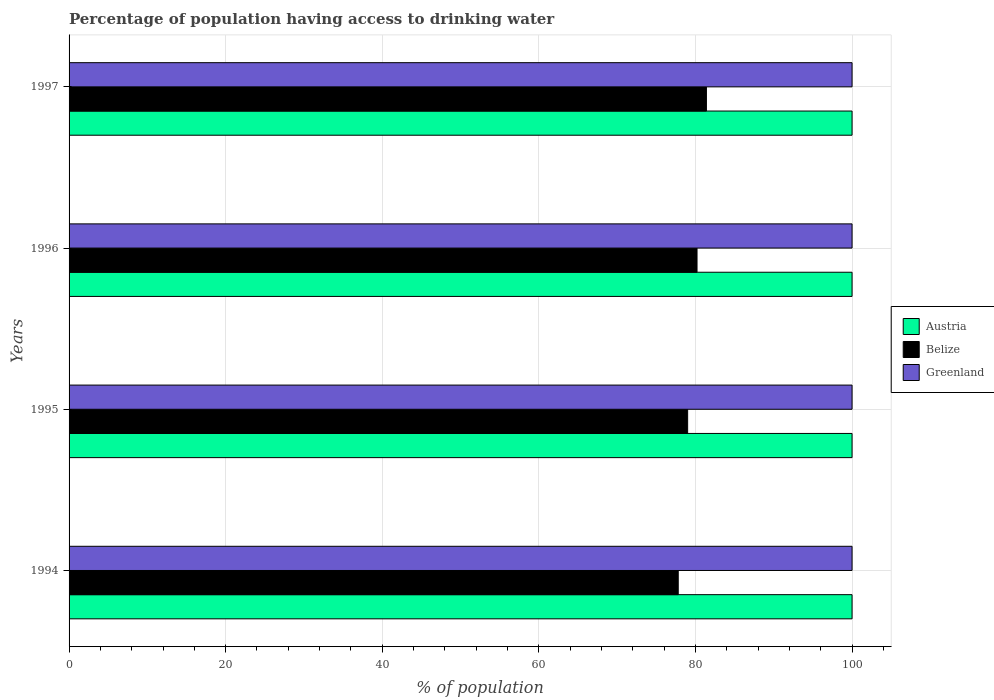How many different coloured bars are there?
Provide a short and direct response. 3. Are the number of bars per tick equal to the number of legend labels?
Your answer should be compact. Yes. Are the number of bars on each tick of the Y-axis equal?
Give a very brief answer. Yes. How many bars are there on the 4th tick from the bottom?
Provide a short and direct response. 3. In how many cases, is the number of bars for a given year not equal to the number of legend labels?
Your answer should be compact. 0. What is the percentage of population having access to drinking water in Belize in 1997?
Provide a succinct answer. 81.4. Across all years, what is the maximum percentage of population having access to drinking water in Austria?
Provide a succinct answer. 100. Across all years, what is the minimum percentage of population having access to drinking water in Belize?
Your answer should be very brief. 77.8. In which year was the percentage of population having access to drinking water in Belize maximum?
Provide a short and direct response. 1997. What is the total percentage of population having access to drinking water in Belize in the graph?
Ensure brevity in your answer.  318.4. What is the difference between the percentage of population having access to drinking water in Belize in 1995 and that in 1997?
Provide a short and direct response. -2.4. What is the difference between the percentage of population having access to drinking water in Greenland in 1996 and the percentage of population having access to drinking water in Austria in 1995?
Your answer should be compact. 0. What is the average percentage of population having access to drinking water in Austria per year?
Keep it short and to the point. 100. In the year 1994, what is the difference between the percentage of population having access to drinking water in Belize and percentage of population having access to drinking water in Greenland?
Your answer should be very brief. -22.2. What is the ratio of the percentage of population having access to drinking water in Austria in 1996 to that in 1997?
Keep it short and to the point. 1. Is the percentage of population having access to drinking water in Greenland in 1995 less than that in 1997?
Your answer should be very brief. No. Is the difference between the percentage of population having access to drinking water in Belize in 1994 and 1995 greater than the difference between the percentage of population having access to drinking water in Greenland in 1994 and 1995?
Your answer should be compact. No. What is the difference between the highest and the second highest percentage of population having access to drinking water in Belize?
Make the answer very short. 1.2. What is the difference between the highest and the lowest percentage of population having access to drinking water in Greenland?
Provide a succinct answer. 0. Is the sum of the percentage of population having access to drinking water in Greenland in 1994 and 1996 greater than the maximum percentage of population having access to drinking water in Austria across all years?
Offer a terse response. Yes. What does the 3rd bar from the bottom in 1995 represents?
Your answer should be compact. Greenland. Is it the case that in every year, the sum of the percentage of population having access to drinking water in Belize and percentage of population having access to drinking water in Austria is greater than the percentage of population having access to drinking water in Greenland?
Your answer should be compact. Yes. How many bars are there?
Provide a short and direct response. 12. What is the difference between two consecutive major ticks on the X-axis?
Your answer should be very brief. 20. Does the graph contain any zero values?
Ensure brevity in your answer.  No. How many legend labels are there?
Keep it short and to the point. 3. What is the title of the graph?
Keep it short and to the point. Percentage of population having access to drinking water. What is the label or title of the X-axis?
Your response must be concise. % of population. What is the % of population of Austria in 1994?
Offer a terse response. 100. What is the % of population of Belize in 1994?
Ensure brevity in your answer.  77.8. What is the % of population of Greenland in 1994?
Offer a terse response. 100. What is the % of population in Austria in 1995?
Make the answer very short. 100. What is the % of population in Belize in 1995?
Provide a short and direct response. 79. What is the % of population of Greenland in 1995?
Make the answer very short. 100. What is the % of population of Austria in 1996?
Offer a very short reply. 100. What is the % of population of Belize in 1996?
Give a very brief answer. 80.2. What is the % of population in Austria in 1997?
Offer a terse response. 100. What is the % of population of Belize in 1997?
Make the answer very short. 81.4. Across all years, what is the maximum % of population of Belize?
Your answer should be compact. 81.4. Across all years, what is the maximum % of population in Greenland?
Offer a very short reply. 100. Across all years, what is the minimum % of population in Austria?
Give a very brief answer. 100. Across all years, what is the minimum % of population in Belize?
Your answer should be compact. 77.8. What is the total % of population in Austria in the graph?
Give a very brief answer. 400. What is the total % of population in Belize in the graph?
Provide a succinct answer. 318.4. What is the difference between the % of population of Austria in 1994 and that in 1995?
Offer a terse response. 0. What is the difference between the % of population of Greenland in 1994 and that in 1995?
Ensure brevity in your answer.  0. What is the difference between the % of population in Belize in 1994 and that in 1996?
Provide a short and direct response. -2.4. What is the difference between the % of population in Greenland in 1994 and that in 1996?
Offer a terse response. 0. What is the difference between the % of population in Austria in 1994 and that in 1997?
Your response must be concise. 0. What is the difference between the % of population in Greenland in 1994 and that in 1997?
Give a very brief answer. 0. What is the difference between the % of population in Belize in 1995 and that in 1997?
Keep it short and to the point. -2.4. What is the difference between the % of population in Greenland in 1995 and that in 1997?
Offer a terse response. 0. What is the difference between the % of population of Austria in 1996 and that in 1997?
Offer a very short reply. 0. What is the difference between the % of population in Belize in 1996 and that in 1997?
Provide a succinct answer. -1.2. What is the difference between the % of population in Greenland in 1996 and that in 1997?
Make the answer very short. 0. What is the difference between the % of population in Austria in 1994 and the % of population in Greenland in 1995?
Offer a very short reply. 0. What is the difference between the % of population of Belize in 1994 and the % of population of Greenland in 1995?
Keep it short and to the point. -22.2. What is the difference between the % of population in Austria in 1994 and the % of population in Belize in 1996?
Provide a succinct answer. 19.8. What is the difference between the % of population of Austria in 1994 and the % of population of Greenland in 1996?
Your answer should be compact. 0. What is the difference between the % of population of Belize in 1994 and the % of population of Greenland in 1996?
Give a very brief answer. -22.2. What is the difference between the % of population in Austria in 1994 and the % of population in Greenland in 1997?
Provide a short and direct response. 0. What is the difference between the % of population of Belize in 1994 and the % of population of Greenland in 1997?
Your answer should be compact. -22.2. What is the difference between the % of population of Austria in 1995 and the % of population of Belize in 1996?
Offer a terse response. 19.8. What is the difference between the % of population of Austria in 1995 and the % of population of Greenland in 1996?
Make the answer very short. 0. What is the difference between the % of population in Austria in 1995 and the % of population in Belize in 1997?
Provide a short and direct response. 18.6. What is the difference between the % of population of Austria in 1995 and the % of population of Greenland in 1997?
Your answer should be very brief. 0. What is the difference between the % of population of Austria in 1996 and the % of population of Greenland in 1997?
Keep it short and to the point. 0. What is the difference between the % of population in Belize in 1996 and the % of population in Greenland in 1997?
Ensure brevity in your answer.  -19.8. What is the average % of population in Austria per year?
Give a very brief answer. 100. What is the average % of population in Belize per year?
Keep it short and to the point. 79.6. What is the average % of population of Greenland per year?
Provide a succinct answer. 100. In the year 1994, what is the difference between the % of population of Austria and % of population of Belize?
Keep it short and to the point. 22.2. In the year 1994, what is the difference between the % of population in Austria and % of population in Greenland?
Make the answer very short. 0. In the year 1994, what is the difference between the % of population in Belize and % of population in Greenland?
Make the answer very short. -22.2. In the year 1995, what is the difference between the % of population of Austria and % of population of Belize?
Provide a short and direct response. 21. In the year 1995, what is the difference between the % of population in Belize and % of population in Greenland?
Keep it short and to the point. -21. In the year 1996, what is the difference between the % of population of Austria and % of population of Belize?
Your answer should be compact. 19.8. In the year 1996, what is the difference between the % of population in Austria and % of population in Greenland?
Give a very brief answer. 0. In the year 1996, what is the difference between the % of population of Belize and % of population of Greenland?
Your answer should be compact. -19.8. In the year 1997, what is the difference between the % of population of Austria and % of population of Belize?
Provide a succinct answer. 18.6. In the year 1997, what is the difference between the % of population in Belize and % of population in Greenland?
Your response must be concise. -18.6. What is the ratio of the % of population in Austria in 1994 to that in 1995?
Your response must be concise. 1. What is the ratio of the % of population in Belize in 1994 to that in 1995?
Provide a succinct answer. 0.98. What is the ratio of the % of population of Greenland in 1994 to that in 1995?
Your answer should be compact. 1. What is the ratio of the % of population of Belize in 1994 to that in 1996?
Give a very brief answer. 0.97. What is the ratio of the % of population in Greenland in 1994 to that in 1996?
Provide a short and direct response. 1. What is the ratio of the % of population of Belize in 1994 to that in 1997?
Offer a very short reply. 0.96. What is the ratio of the % of population in Greenland in 1994 to that in 1997?
Give a very brief answer. 1. What is the ratio of the % of population of Austria in 1995 to that in 1996?
Ensure brevity in your answer.  1. What is the ratio of the % of population of Greenland in 1995 to that in 1996?
Give a very brief answer. 1. What is the ratio of the % of population in Belize in 1995 to that in 1997?
Your answer should be compact. 0.97. 